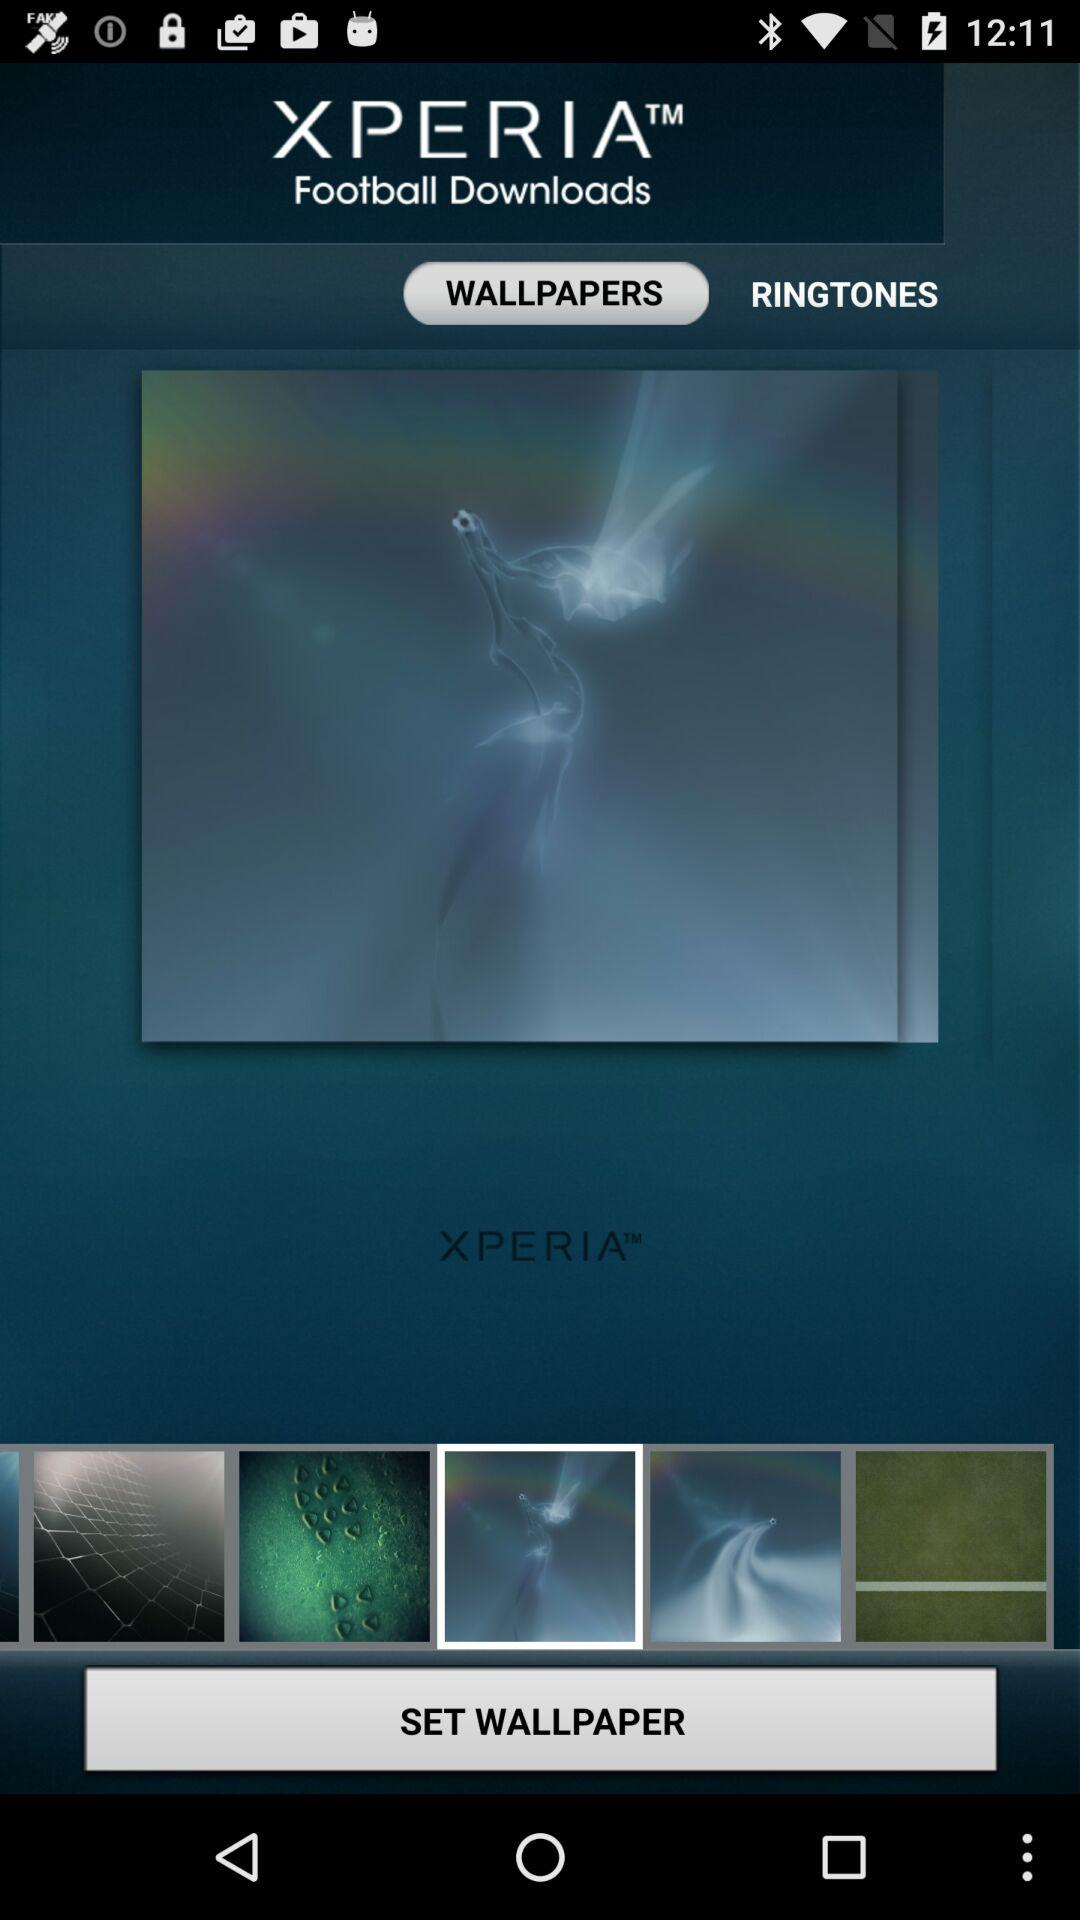Which tab am I using? You are using the tab "WALLPAPERS". 